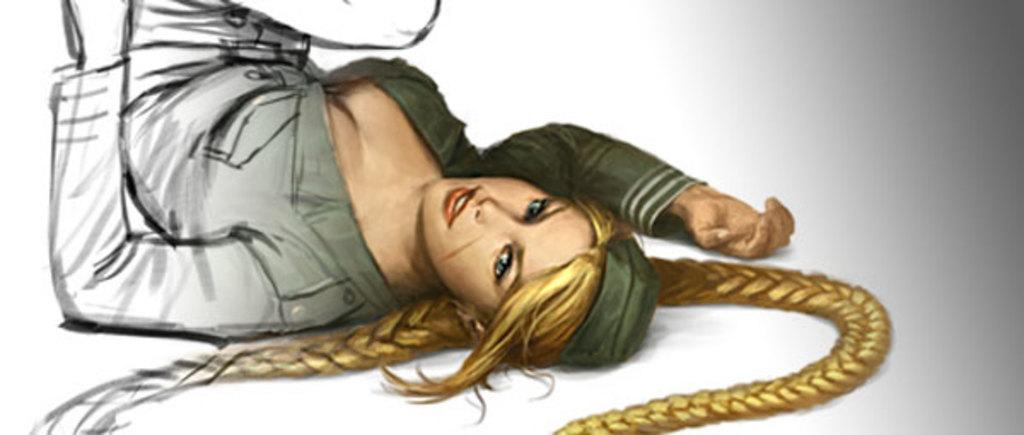What type of image is depicted in the picture? There is a cartoon image of a woman in the picture. What is the woman doing in the image? The woman is lying on the floor in the image. What can be observed about the woman's hair in the image? The woman has two long hair plaits in the image. What type of sheet is covering the woman in the image? There is: There is no sheet covering the woman in the image; she is depicted as a cartoon character lying on the floor. 